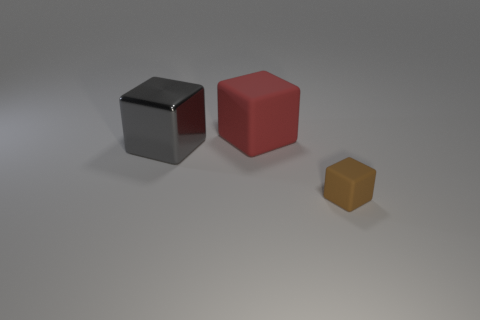Add 2 large objects. How many objects exist? 5 Subtract all large blocks. How many blocks are left? 1 Subtract 2 blocks. How many blocks are left? 1 Subtract all brown cubes. How many cubes are left? 2 Add 3 large gray shiny cubes. How many large gray shiny cubes exist? 4 Subtract 0 green cylinders. How many objects are left? 3 Subtract all blue cubes. Subtract all brown balls. How many cubes are left? 3 Subtract all cyan cylinders. How many purple blocks are left? 0 Subtract all small cyan spheres. Subtract all small matte cubes. How many objects are left? 2 Add 2 objects. How many objects are left? 5 